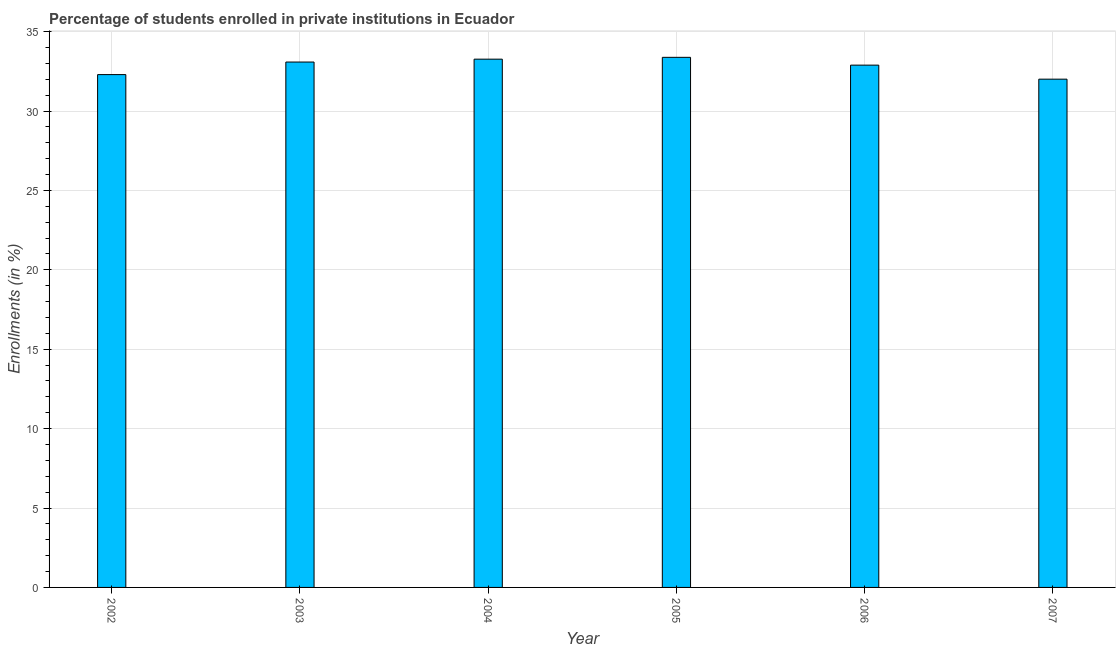What is the title of the graph?
Offer a very short reply. Percentage of students enrolled in private institutions in Ecuador. What is the label or title of the Y-axis?
Keep it short and to the point. Enrollments (in %). What is the enrollments in private institutions in 2002?
Provide a succinct answer. 32.3. Across all years, what is the maximum enrollments in private institutions?
Make the answer very short. 33.38. Across all years, what is the minimum enrollments in private institutions?
Keep it short and to the point. 32.01. In which year was the enrollments in private institutions maximum?
Make the answer very short. 2005. What is the sum of the enrollments in private institutions?
Your answer should be compact. 196.93. What is the difference between the enrollments in private institutions in 2002 and 2004?
Give a very brief answer. -0.97. What is the average enrollments in private institutions per year?
Offer a terse response. 32.82. What is the median enrollments in private institutions?
Keep it short and to the point. 32.99. Is the enrollments in private institutions in 2003 less than that in 2005?
Ensure brevity in your answer.  Yes. What is the difference between the highest and the second highest enrollments in private institutions?
Offer a terse response. 0.12. What is the difference between the highest and the lowest enrollments in private institutions?
Give a very brief answer. 1.37. How many bars are there?
Your answer should be very brief. 6. What is the difference between two consecutive major ticks on the Y-axis?
Your answer should be compact. 5. What is the Enrollments (in %) of 2002?
Offer a very short reply. 32.3. What is the Enrollments (in %) of 2003?
Ensure brevity in your answer.  33.09. What is the Enrollments (in %) in 2004?
Offer a very short reply. 33.27. What is the Enrollments (in %) in 2005?
Offer a terse response. 33.38. What is the Enrollments (in %) of 2006?
Your response must be concise. 32.89. What is the Enrollments (in %) in 2007?
Give a very brief answer. 32.01. What is the difference between the Enrollments (in %) in 2002 and 2003?
Your response must be concise. -0.79. What is the difference between the Enrollments (in %) in 2002 and 2004?
Offer a very short reply. -0.97. What is the difference between the Enrollments (in %) in 2002 and 2005?
Give a very brief answer. -1.09. What is the difference between the Enrollments (in %) in 2002 and 2006?
Provide a succinct answer. -0.6. What is the difference between the Enrollments (in %) in 2002 and 2007?
Keep it short and to the point. 0.29. What is the difference between the Enrollments (in %) in 2003 and 2004?
Give a very brief answer. -0.18. What is the difference between the Enrollments (in %) in 2003 and 2005?
Ensure brevity in your answer.  -0.3. What is the difference between the Enrollments (in %) in 2003 and 2006?
Offer a terse response. 0.2. What is the difference between the Enrollments (in %) in 2003 and 2007?
Your answer should be compact. 1.08. What is the difference between the Enrollments (in %) in 2004 and 2005?
Make the answer very short. -0.12. What is the difference between the Enrollments (in %) in 2004 and 2006?
Your response must be concise. 0.38. What is the difference between the Enrollments (in %) in 2004 and 2007?
Give a very brief answer. 1.26. What is the difference between the Enrollments (in %) in 2005 and 2006?
Your answer should be very brief. 0.49. What is the difference between the Enrollments (in %) in 2005 and 2007?
Ensure brevity in your answer.  1.37. What is the difference between the Enrollments (in %) in 2006 and 2007?
Provide a short and direct response. 0.88. What is the ratio of the Enrollments (in %) in 2002 to that in 2004?
Keep it short and to the point. 0.97. What is the ratio of the Enrollments (in %) in 2002 to that in 2005?
Keep it short and to the point. 0.97. What is the ratio of the Enrollments (in %) in 2002 to that in 2006?
Offer a very short reply. 0.98. What is the ratio of the Enrollments (in %) in 2002 to that in 2007?
Provide a short and direct response. 1.01. What is the ratio of the Enrollments (in %) in 2003 to that in 2004?
Make the answer very short. 0.99. What is the ratio of the Enrollments (in %) in 2003 to that in 2005?
Your response must be concise. 0.99. What is the ratio of the Enrollments (in %) in 2003 to that in 2006?
Your response must be concise. 1.01. What is the ratio of the Enrollments (in %) in 2003 to that in 2007?
Offer a terse response. 1.03. What is the ratio of the Enrollments (in %) in 2004 to that in 2005?
Make the answer very short. 1. What is the ratio of the Enrollments (in %) in 2004 to that in 2006?
Keep it short and to the point. 1.01. What is the ratio of the Enrollments (in %) in 2004 to that in 2007?
Provide a succinct answer. 1.04. What is the ratio of the Enrollments (in %) in 2005 to that in 2006?
Keep it short and to the point. 1.01. What is the ratio of the Enrollments (in %) in 2005 to that in 2007?
Provide a succinct answer. 1.04. What is the ratio of the Enrollments (in %) in 2006 to that in 2007?
Keep it short and to the point. 1.03. 